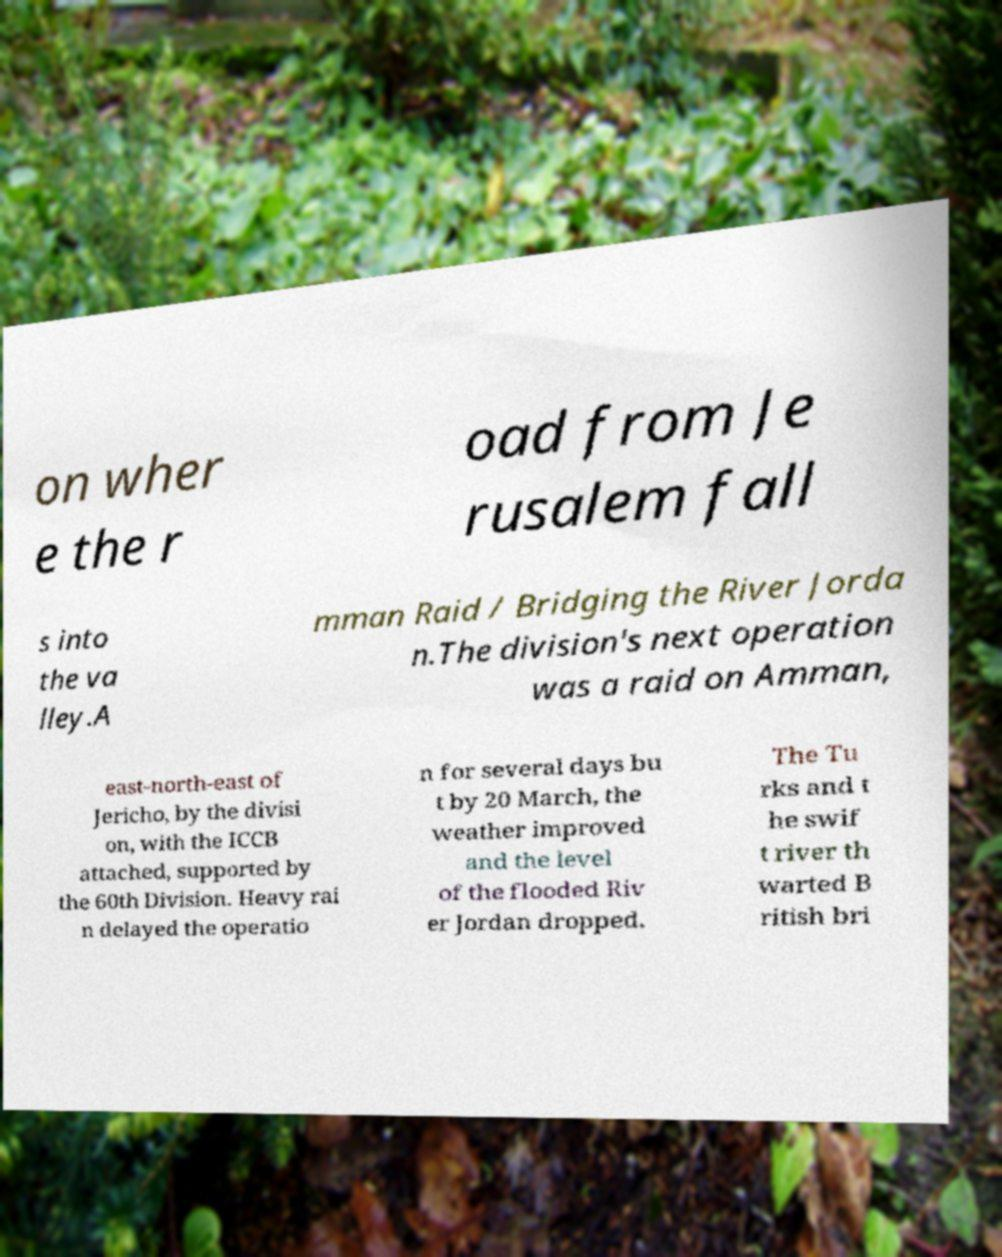Please identify and transcribe the text found in this image. on wher e the r oad from Je rusalem fall s into the va lley.A mman Raid / Bridging the River Jorda n.The division's next operation was a raid on Amman, east-north-east of Jericho, by the divisi on, with the ICCB attached, supported by the 60th Division. Heavy rai n delayed the operatio n for several days bu t by 20 March, the weather improved and the level of the flooded Riv er Jordan dropped. The Tu rks and t he swif t river th warted B ritish bri 